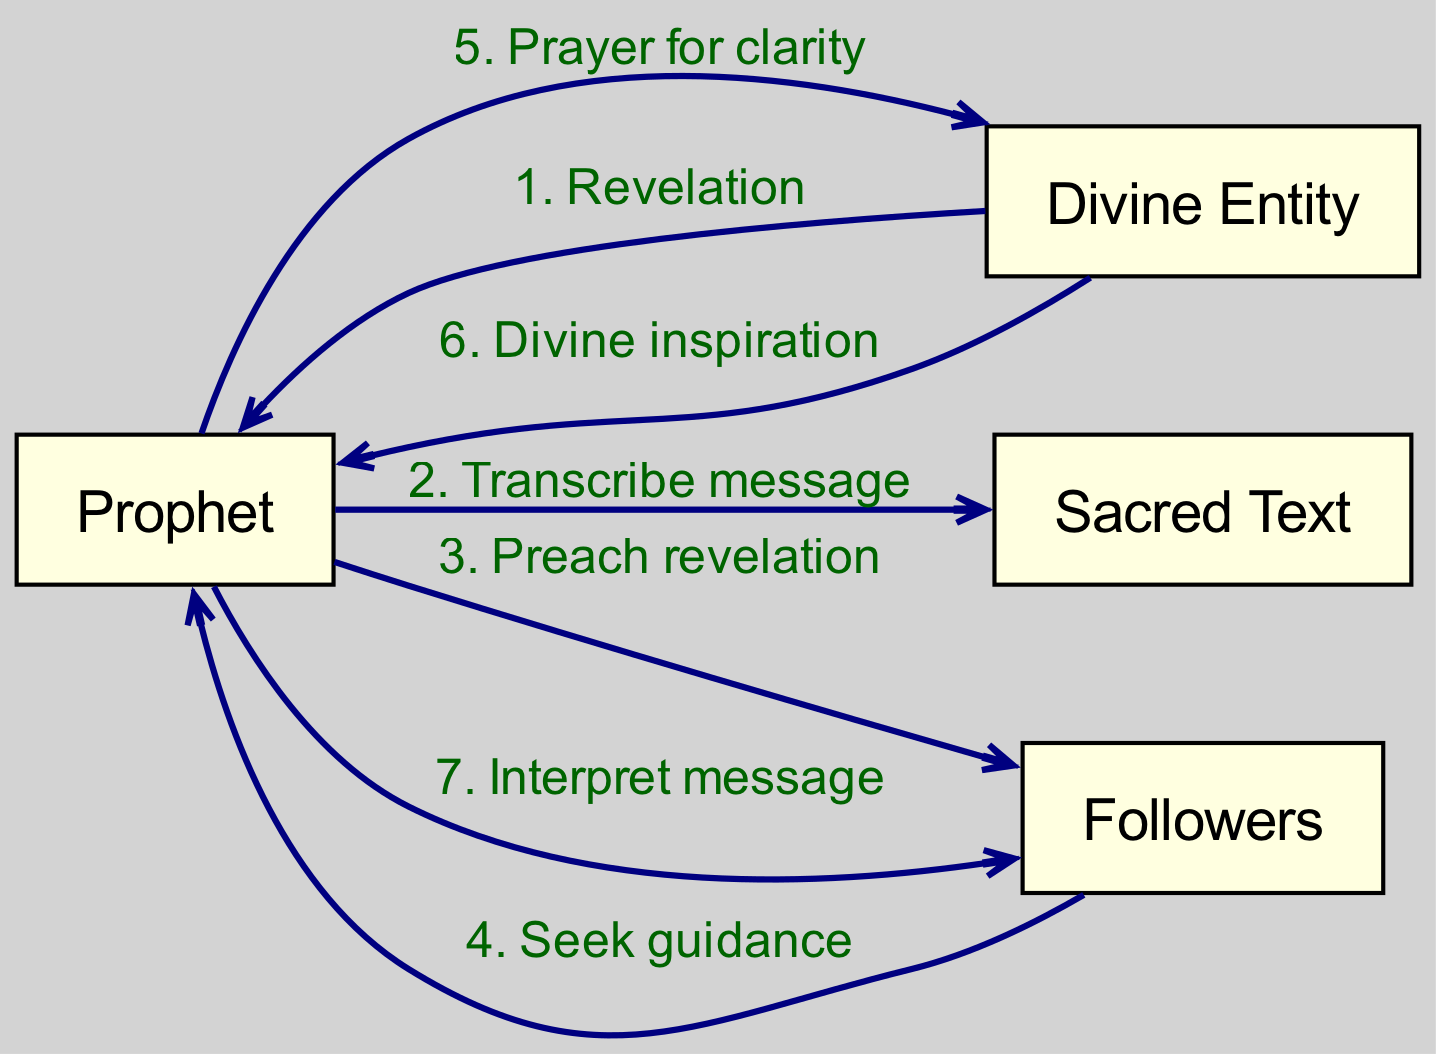What is the total number of participants in the diagram? The diagram lists four participants: Prophet, Divine Entity, Sacred Text, and Followers. Counting these gives a total of four participants.
Answer: 4 Who does the Prophet preach to after receiving a revelation? According to the diagram, after receiving a revelation, the Prophet preaches to the Followers. This is indicated in the flow of communication from the Prophet to the Followers.
Answer: Followers What message does the Divine Entity send to the Prophet first? The first message from the Divine Entity to the Prophet is "Revelation," as shown at the start of the sequence in the diagram.
Answer: Revelation What is the second step the Prophet takes after receiving the revelation? After receiving the revelation, the Prophet transcribes the message into the Sacred Text, as indicated in the second message flowing from the Prophet to the Sacred Text.
Answer: Transcribe message How many messages are sent from the Prophet to the Followers? The diagram shows two distinct messages being sent from the Prophet to the Followers: “Preach revelation” and “Interpret message.” Adding these together gives a total of two messages.
Answer: 2 What does the Prophet seek from the Divine Entity after preaching? The Prophet sends a message to the Divine Entity requesting "Prayer for clarity," as noted in the communication flow after preaching to the Followers.
Answer: Prayer for clarity Which entity provides divine inspiration to the Prophet? The diagram indicates that the Divine Entity sends a message of "Divine inspiration" to the Prophet. This response follows the Prophet's prayer for clarity, reflecting a direct flow of inspiration.
Answer: Divine Entity What action do the Followers take towards the Prophet? The Followers seek guidance from the Prophet, as indicated by the communication flow from the Followers to the Prophet in the diagram.
Answer: Seek guidance What is the primary purpose of the Sacred Text in the communication sequence? The Sacred Text serves as a medium through which the Prophet transcribes the revelation, signifying its role in recording divine messages for future guidance and interpretation.
Answer: Transcribe message 